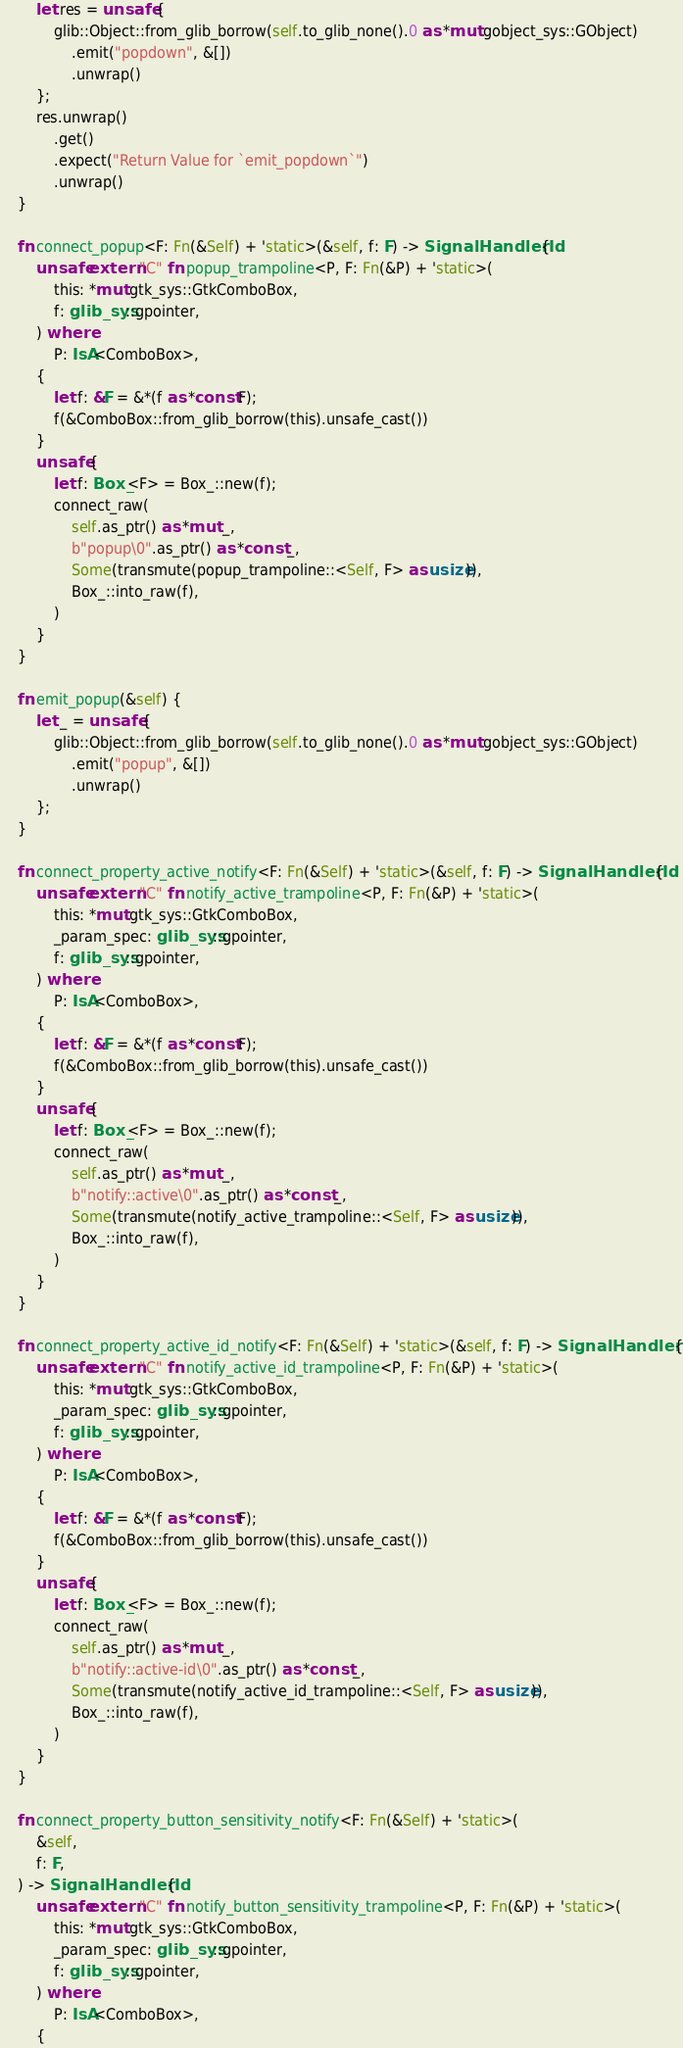Convert code to text. <code><loc_0><loc_0><loc_500><loc_500><_Rust_>        let res = unsafe {
            glib::Object::from_glib_borrow(self.to_glib_none().0 as *mut gobject_sys::GObject)
                .emit("popdown", &[])
                .unwrap()
        };
        res.unwrap()
            .get()
            .expect("Return Value for `emit_popdown`")
            .unwrap()
    }

    fn connect_popup<F: Fn(&Self) + 'static>(&self, f: F) -> SignalHandlerId {
        unsafe extern "C" fn popup_trampoline<P, F: Fn(&P) + 'static>(
            this: *mut gtk_sys::GtkComboBox,
            f: glib_sys::gpointer,
        ) where
            P: IsA<ComboBox>,
        {
            let f: &F = &*(f as *const F);
            f(&ComboBox::from_glib_borrow(this).unsafe_cast())
        }
        unsafe {
            let f: Box_<F> = Box_::new(f);
            connect_raw(
                self.as_ptr() as *mut _,
                b"popup\0".as_ptr() as *const _,
                Some(transmute(popup_trampoline::<Self, F> as usize)),
                Box_::into_raw(f),
            )
        }
    }

    fn emit_popup(&self) {
        let _ = unsafe {
            glib::Object::from_glib_borrow(self.to_glib_none().0 as *mut gobject_sys::GObject)
                .emit("popup", &[])
                .unwrap()
        };
    }

    fn connect_property_active_notify<F: Fn(&Self) + 'static>(&self, f: F) -> SignalHandlerId {
        unsafe extern "C" fn notify_active_trampoline<P, F: Fn(&P) + 'static>(
            this: *mut gtk_sys::GtkComboBox,
            _param_spec: glib_sys::gpointer,
            f: glib_sys::gpointer,
        ) where
            P: IsA<ComboBox>,
        {
            let f: &F = &*(f as *const F);
            f(&ComboBox::from_glib_borrow(this).unsafe_cast())
        }
        unsafe {
            let f: Box_<F> = Box_::new(f);
            connect_raw(
                self.as_ptr() as *mut _,
                b"notify::active\0".as_ptr() as *const _,
                Some(transmute(notify_active_trampoline::<Self, F> as usize)),
                Box_::into_raw(f),
            )
        }
    }

    fn connect_property_active_id_notify<F: Fn(&Self) + 'static>(&self, f: F) -> SignalHandlerId {
        unsafe extern "C" fn notify_active_id_trampoline<P, F: Fn(&P) + 'static>(
            this: *mut gtk_sys::GtkComboBox,
            _param_spec: glib_sys::gpointer,
            f: glib_sys::gpointer,
        ) where
            P: IsA<ComboBox>,
        {
            let f: &F = &*(f as *const F);
            f(&ComboBox::from_glib_borrow(this).unsafe_cast())
        }
        unsafe {
            let f: Box_<F> = Box_::new(f);
            connect_raw(
                self.as_ptr() as *mut _,
                b"notify::active-id\0".as_ptr() as *const _,
                Some(transmute(notify_active_id_trampoline::<Self, F> as usize)),
                Box_::into_raw(f),
            )
        }
    }

    fn connect_property_button_sensitivity_notify<F: Fn(&Self) + 'static>(
        &self,
        f: F,
    ) -> SignalHandlerId {
        unsafe extern "C" fn notify_button_sensitivity_trampoline<P, F: Fn(&P) + 'static>(
            this: *mut gtk_sys::GtkComboBox,
            _param_spec: glib_sys::gpointer,
            f: glib_sys::gpointer,
        ) where
            P: IsA<ComboBox>,
        {</code> 